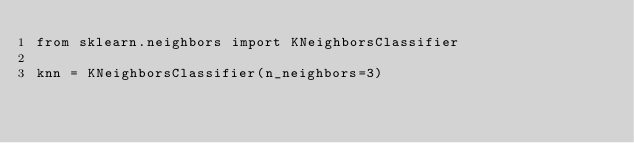Convert code to text. <code><loc_0><loc_0><loc_500><loc_500><_Python_>from sklearn.neighbors import KNeighborsClassifier

knn = KNeighborsClassifier(n_neighbors=3)
</code> 